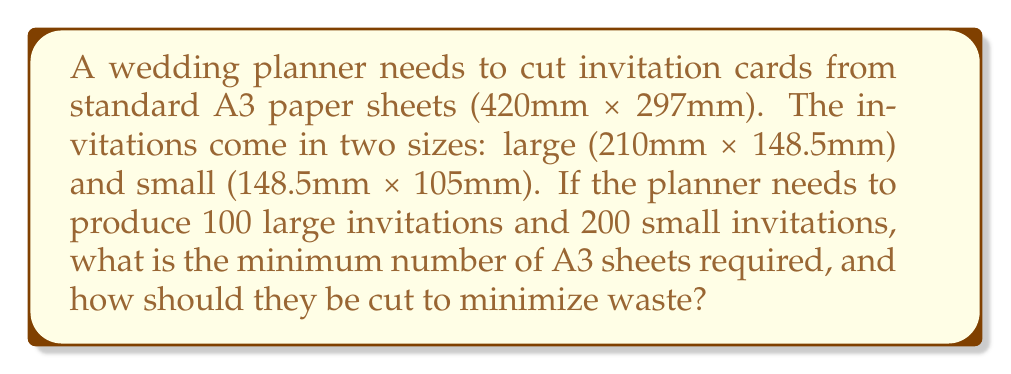Can you answer this question? To solve this problem, we need to determine the most efficient way to cut the A3 sheets for both large and small invitations. Let's approach this step-by-step:

1. Calculate the number of invitations per A3 sheet:
   - For large invitations (210mm x 148.5mm):
     $$\text{Horizontal: } \lfloor \frac{420}{210} \rfloor = 2$$
     $$\text{Vertical: } \lfloor \frac{297}{148.5} \rfloor = 2$$
     Total large invitations per sheet: $2 \times 2 = 4$

   - For small invitations (148.5mm x 105mm):
     $$\text{Horizontal: } \lfloor \frac{420}{148.5} \rfloor = 2$$
     $$\text{Vertical: } \lfloor \frac{297}{105} \rfloor = 2$$
     Total small invitations per sheet: $2 \times 2 = 4$

2. Calculate the number of sheets needed for each size:
   - Large invitations: $\lceil \frac{100}{4} \rceil = 25$ sheets
   - Small invitations: $\lceil \frac{200}{4} \rceil = 50$ sheets

3. Total number of sheets required:
   $25 + 50 = 75$ sheets

4. Check if we can optimize by cutting small invitations from the waste of large invitation sheets:
   - Remaining space on large invitation sheets:
     $420 \text{mm} \times 297 \text{mm} - (210 \text{mm} \times 148.5 \text{mm}) \times 4 = 24,885 \text{mm}^2$
   - Area needed for one small invitation:
     $148.5 \text{mm} \times 105 \text{mm} = 15,592.5 \text{mm}^2$

   We can fit one small invitation in the remaining space of each large invitation sheet.

5. Recalculate the number of sheets needed:
   - 25 sheets for large invitations, which also produce 25 small invitations
   - Remaining small invitations: $200 - 25 = 175$
   - Additional sheets for small invitations: $\lceil \frac{175}{4} \rceil = 44$

6. Final number of sheets required:
   $25 + 44 = 69$ sheets

This cutting method minimizes waste and reduces the total number of sheets needed from 75 to 69.
Answer: 69 A3 sheets are required. Cut each sheet into 4 large invitations (210mm x 148.5mm) for the first 25 sheets, using the remaining space for 1 small invitation (148.5mm x 105mm) per sheet. Cut the remaining 44 sheets into 4 small invitations each. 